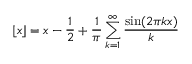<formula> <loc_0><loc_0><loc_500><loc_500>\lfloor x \rfloor = x - { \frac { 1 } { 2 } } + { \frac { 1 } { \pi } } \sum _ { k = 1 } ^ { \infty } { \frac { \sin ( 2 \pi k x ) } { k } }</formula> 